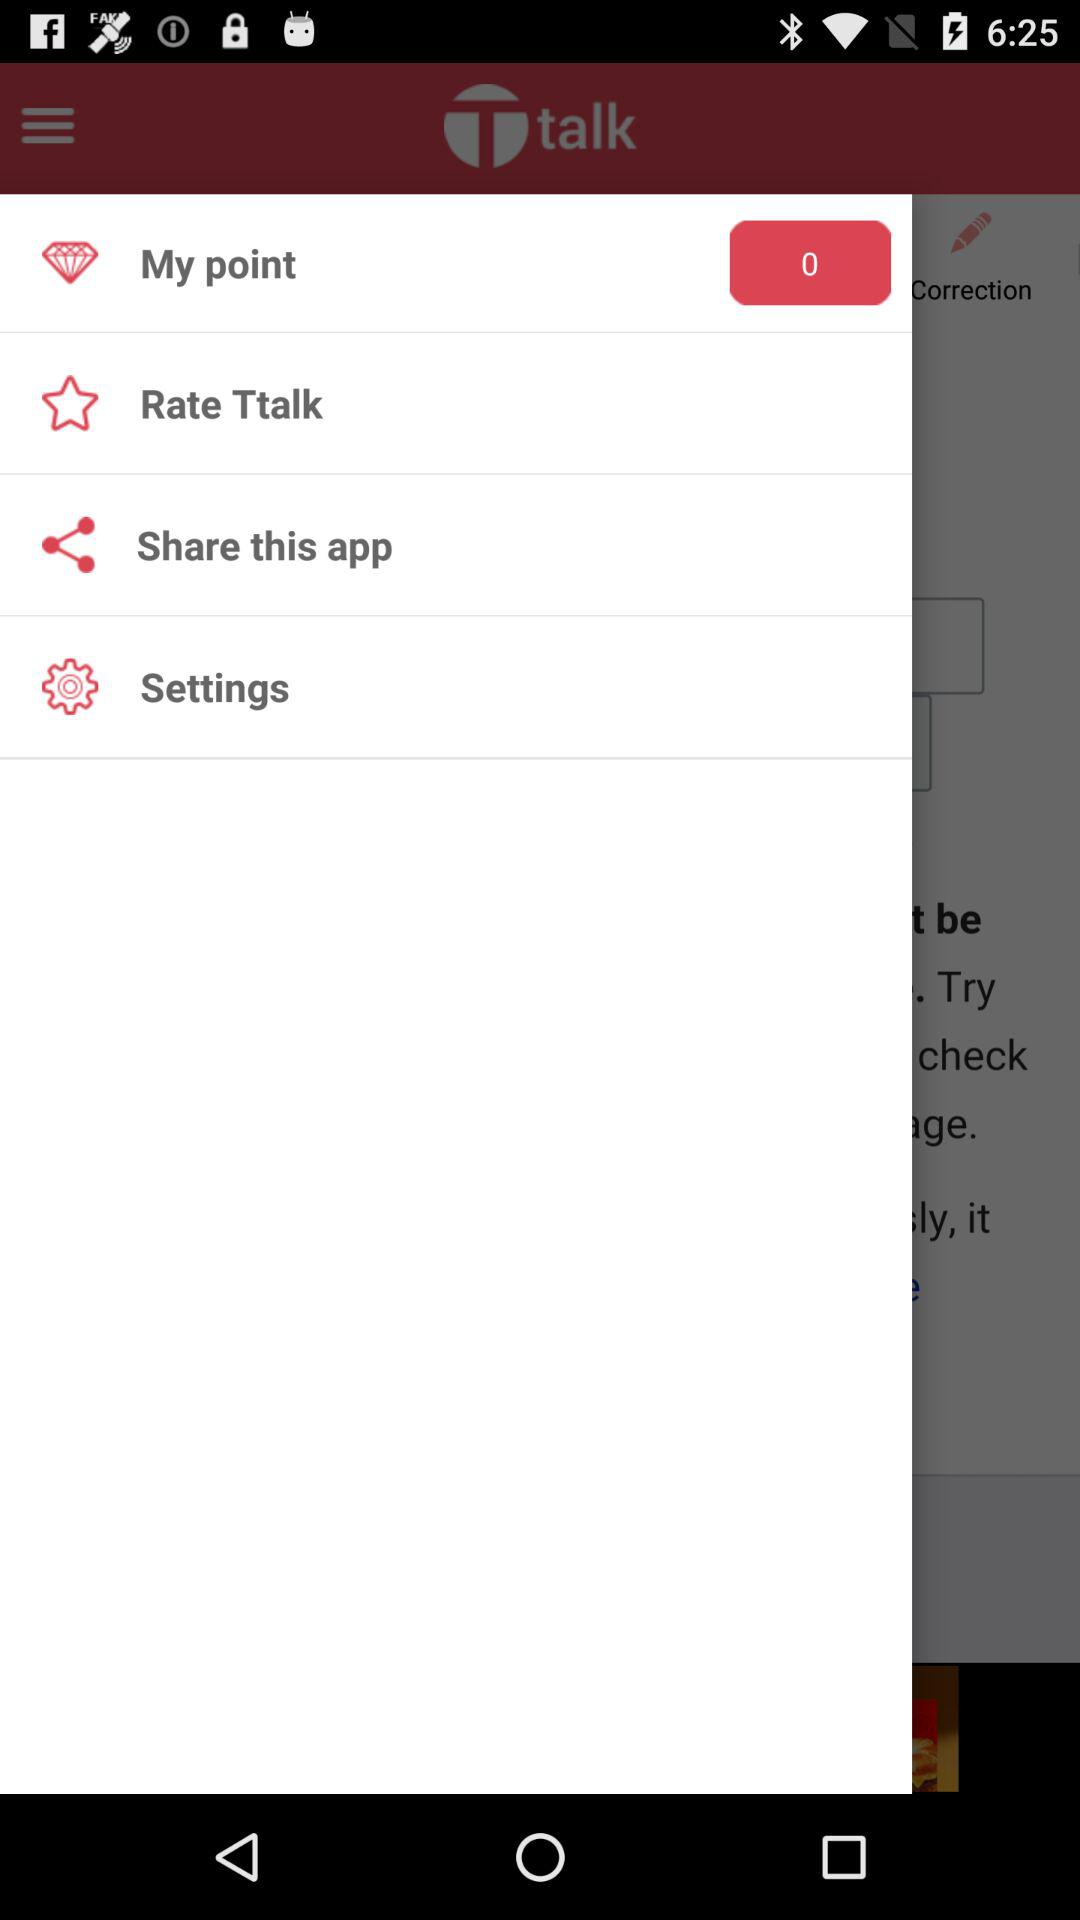What is the remaining "My point"? The remaining "My point" is 0. 